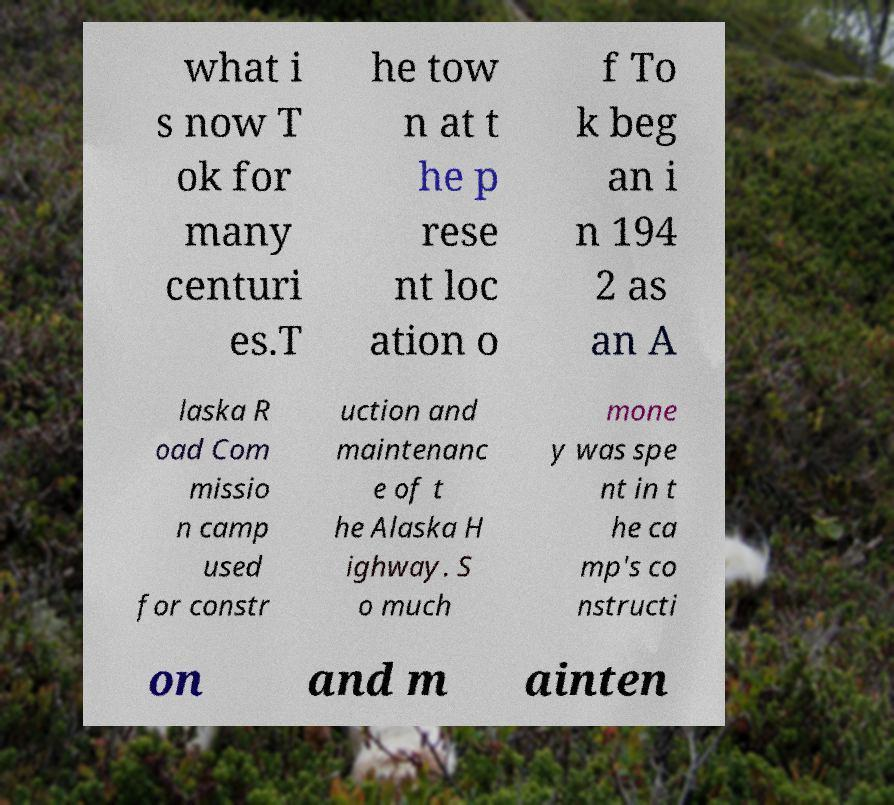What messages or text are displayed in this image? I need them in a readable, typed format. what i s now T ok for many centuri es.T he tow n at t he p rese nt loc ation o f To k beg an i n 194 2 as an A laska R oad Com missio n camp used for constr uction and maintenanc e of t he Alaska H ighway. S o much mone y was spe nt in t he ca mp's co nstructi on and m ainten 